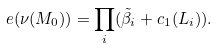Convert formula to latex. <formula><loc_0><loc_0><loc_500><loc_500>e ( \nu ( M _ { 0 } ) ) = \prod _ { i } ( \tilde { \beta } _ { i } + c _ { 1 } ( L _ { i } ) ) .</formula> 